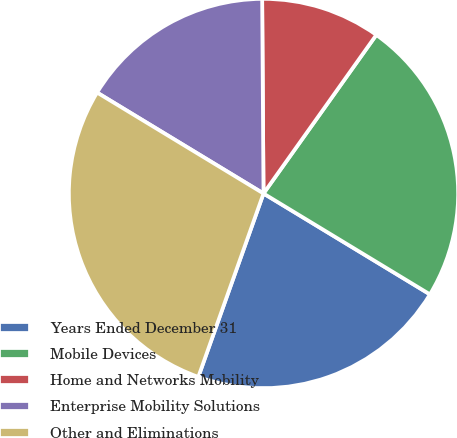Convert chart to OTSL. <chart><loc_0><loc_0><loc_500><loc_500><pie_chart><fcel>Years Ended December 31<fcel>Mobile Devices<fcel>Home and Networks Mobility<fcel>Enterprise Mobility Solutions<fcel>Other and Eliminations<nl><fcel>21.76%<fcel>23.83%<fcel>9.95%<fcel>16.21%<fcel>28.24%<nl></chart> 